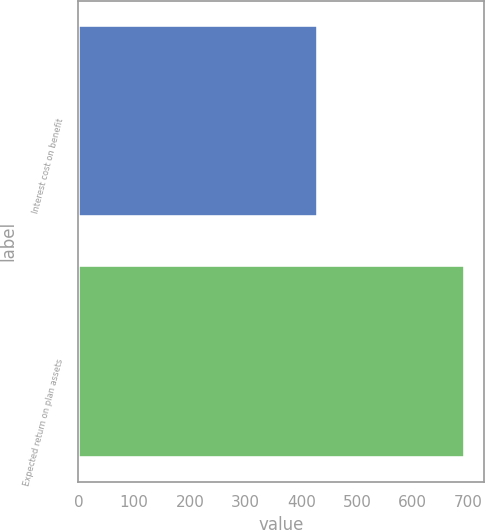<chart> <loc_0><loc_0><loc_500><loc_500><bar_chart><fcel>Interest cost on benefit<fcel>Expected return on plan assets<nl><fcel>431<fcel>694<nl></chart> 